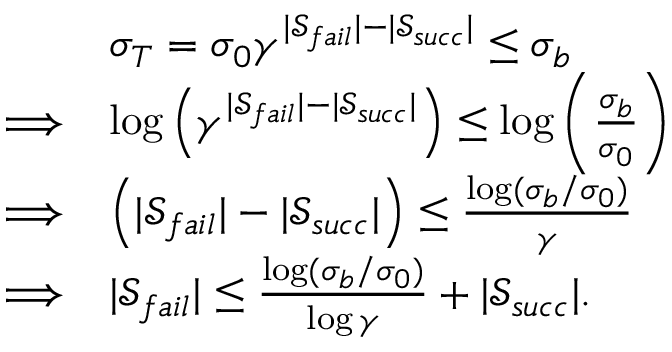<formula> <loc_0><loc_0><loc_500><loc_500>\begin{array} { r l } & { \sigma _ { T } = \sigma _ { 0 } \gamma ^ { | \mathcal { S } _ { f a i l } | - | \mathcal { S } _ { s u c c } | } \leq \sigma _ { b } } \\ { \Longrightarrow } & { \log \left ( \gamma ^ { | \mathcal { S } _ { f a i l } | - | \mathcal { S } _ { s u c c } | } \right ) \leq \log \left ( \frac { \sigma _ { b } } { \sigma _ { 0 } } \right ) } \\ { \Longrightarrow } & { \left ( { | \mathcal { S } _ { f a i l } | - | \mathcal { S } _ { s u c c } | } \right ) \leq \frac { \log ( \sigma _ { b } / \sigma _ { 0 } ) } { \gamma } } \\ { \Longrightarrow } & { | \mathcal { S } _ { f a i l } | \leq \frac { \log ( \sigma _ { b } / \sigma _ { 0 } ) } { \log { \gamma } } + | \mathcal { S } _ { s u c c } | . } \end{array}</formula> 